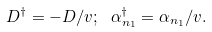Convert formula to latex. <formula><loc_0><loc_0><loc_500><loc_500>D ^ { \dag } = - D / v ; \ \alpha _ { n _ { 1 } } ^ { \dag } = \alpha _ { n _ { 1 } } / v .</formula> 